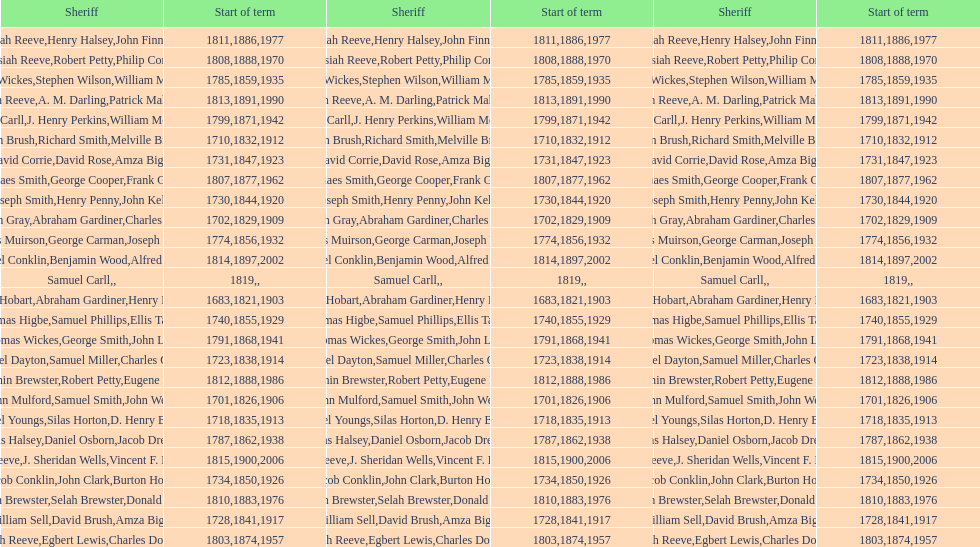When was benjamin brewster's second term of service? 1812. 